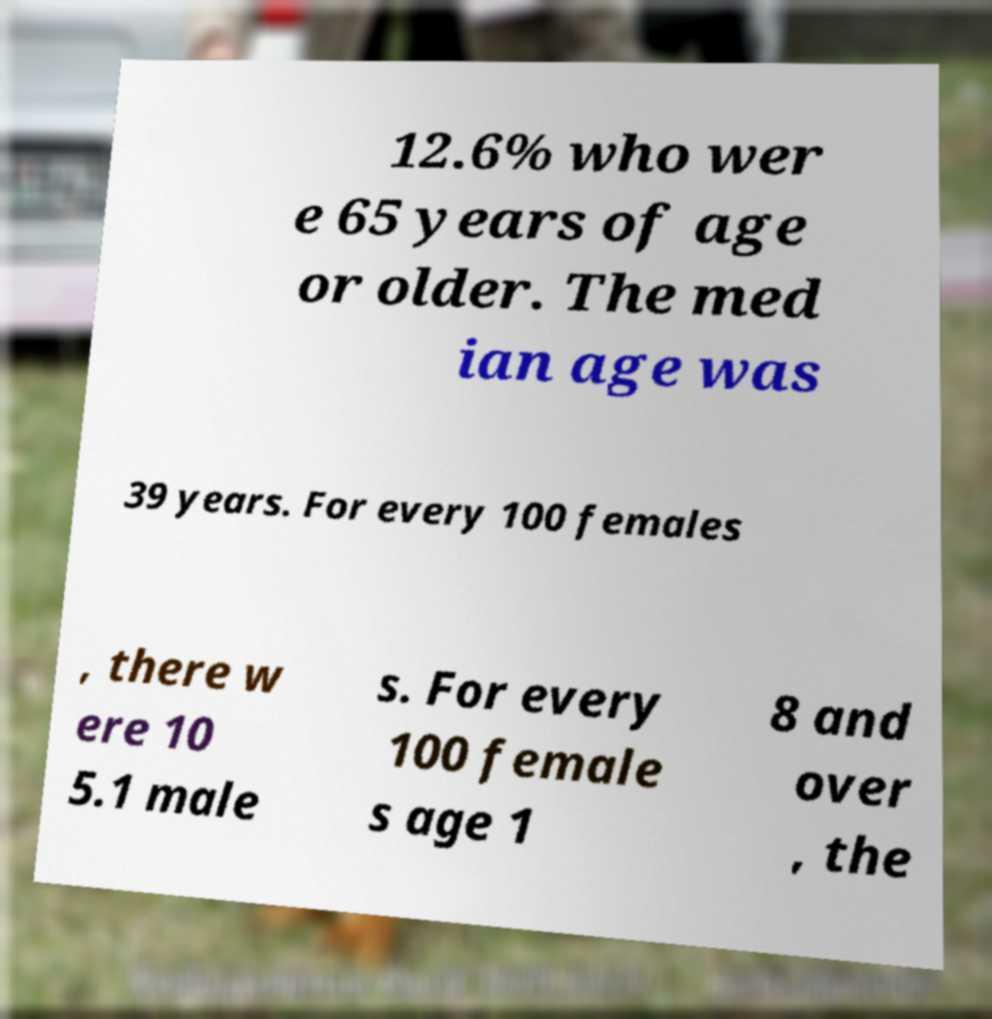Can you accurately transcribe the text from the provided image for me? 12.6% who wer e 65 years of age or older. The med ian age was 39 years. For every 100 females , there w ere 10 5.1 male s. For every 100 female s age 1 8 and over , the 